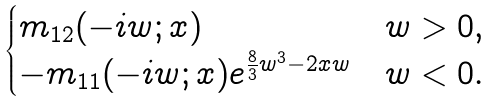Convert formula to latex. <formula><loc_0><loc_0><loc_500><loc_500>\begin{cases} m _ { 1 2 } ( - i w ; x ) & w > 0 , \\ - m _ { 1 1 } ( - i w ; x ) e ^ { \frac { 8 } { 3 } w ^ { 3 } - 2 x w } & w < 0 . \end{cases}</formula> 